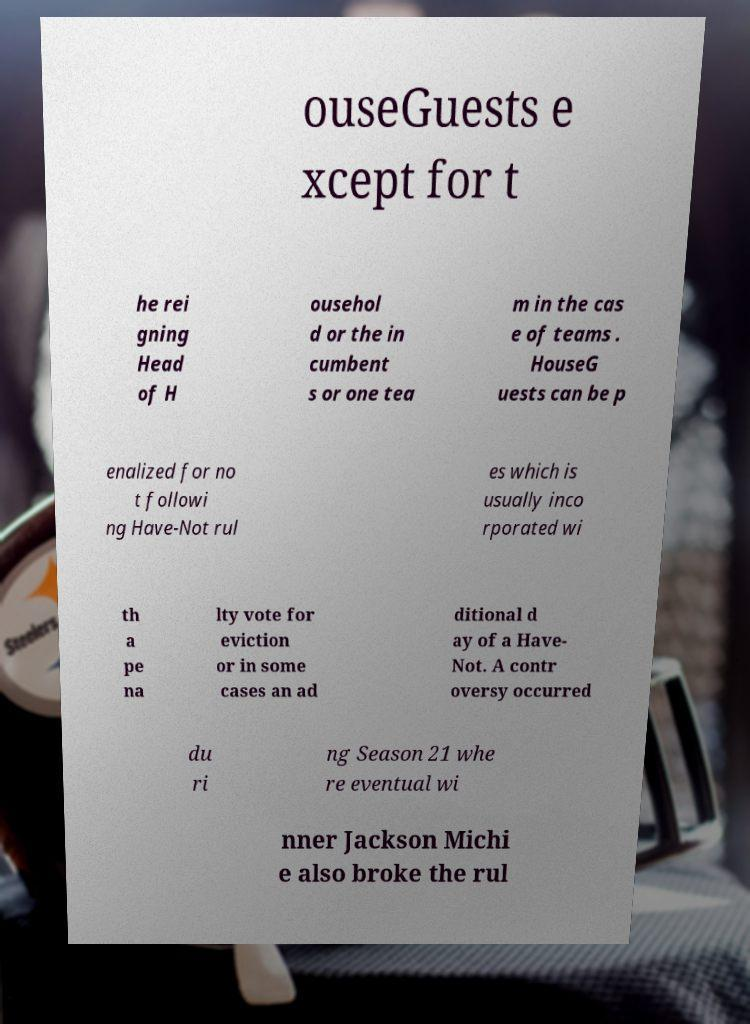What messages or text are displayed in this image? I need them in a readable, typed format. ouseGuests e xcept for t he rei gning Head of H ousehol d or the in cumbent s or one tea m in the cas e of teams . HouseG uests can be p enalized for no t followi ng Have-Not rul es which is usually inco rporated wi th a pe na lty vote for eviction or in some cases an ad ditional d ay of a Have- Not. A contr oversy occurred du ri ng Season 21 whe re eventual wi nner Jackson Michi e also broke the rul 